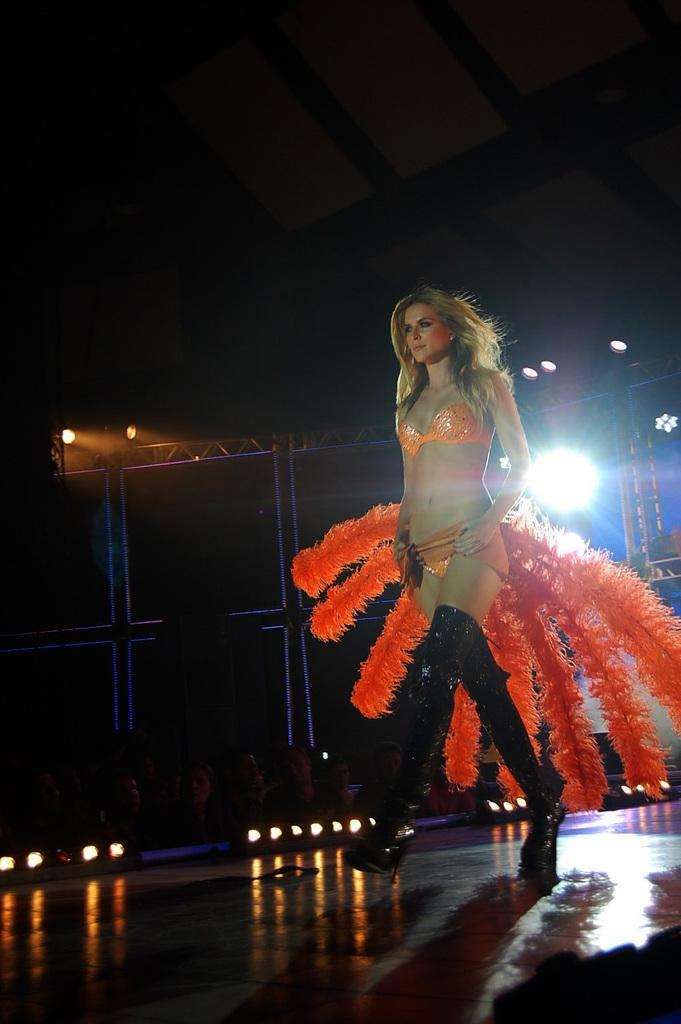Who is the main subject in the image? There is a woman in the image. What is the woman doing in the image? The woman is walking on the floor. What can be seen in the background of the image? There are stage lights and other objects in the background of the image. How would you describe the lighting in the image? The background of the image is dark. What holiday is the woman celebrating in the image? There is no indication of a holiday in the image; it simply shows a woman walking on the floor with stage lights and other objects in the background. Can you tell me how many times the woman's aunt jumps in the image? There is no aunt or jumping depicted in the image. 